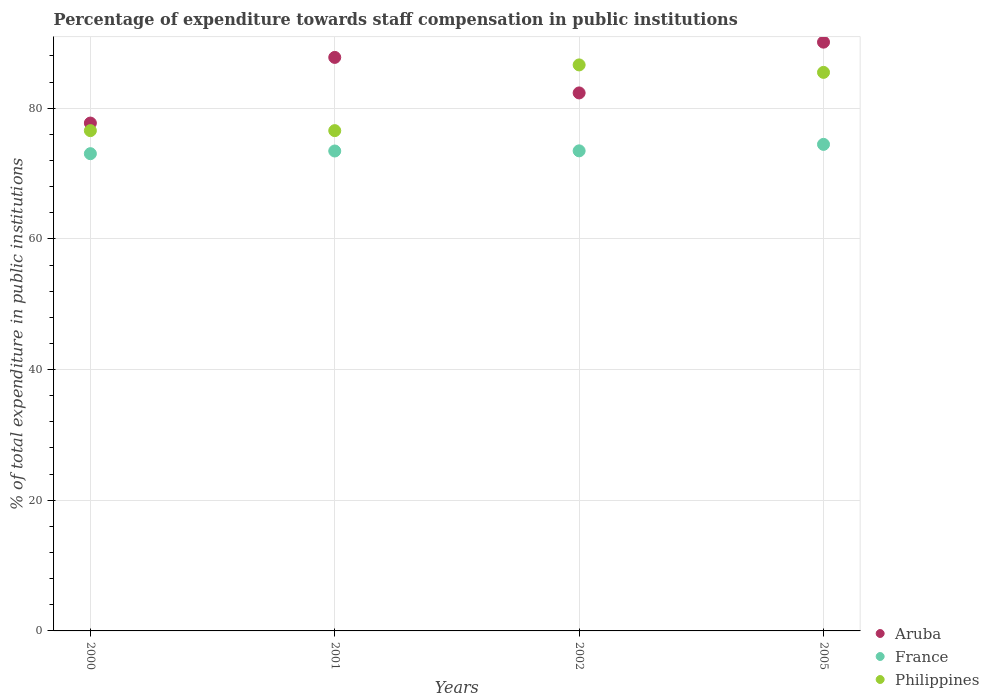What is the percentage of expenditure towards staff compensation in Aruba in 2002?
Provide a short and direct response. 82.34. Across all years, what is the maximum percentage of expenditure towards staff compensation in France?
Offer a terse response. 74.47. Across all years, what is the minimum percentage of expenditure towards staff compensation in Philippines?
Give a very brief answer. 76.57. In which year was the percentage of expenditure towards staff compensation in Aruba maximum?
Ensure brevity in your answer.  2005. In which year was the percentage of expenditure towards staff compensation in Aruba minimum?
Your response must be concise. 2000. What is the total percentage of expenditure towards staff compensation in France in the graph?
Your answer should be very brief. 294.44. What is the difference between the percentage of expenditure towards staff compensation in France in 2002 and that in 2005?
Make the answer very short. -0.99. What is the difference between the percentage of expenditure towards staff compensation in France in 2005 and the percentage of expenditure towards staff compensation in Aruba in 2000?
Your response must be concise. -3.26. What is the average percentage of expenditure towards staff compensation in France per year?
Your answer should be very brief. 73.61. In the year 2001, what is the difference between the percentage of expenditure towards staff compensation in Aruba and percentage of expenditure towards staff compensation in Philippines?
Offer a very short reply. 11.21. What is the ratio of the percentage of expenditure towards staff compensation in France in 2001 to that in 2005?
Ensure brevity in your answer.  0.99. What is the difference between the highest and the second highest percentage of expenditure towards staff compensation in Philippines?
Keep it short and to the point. 1.14. What is the difference between the highest and the lowest percentage of expenditure towards staff compensation in Philippines?
Provide a short and direct response. 10.06. In how many years, is the percentage of expenditure towards staff compensation in Philippines greater than the average percentage of expenditure towards staff compensation in Philippines taken over all years?
Your answer should be compact. 2. Is the sum of the percentage of expenditure towards staff compensation in Aruba in 2001 and 2005 greater than the maximum percentage of expenditure towards staff compensation in Philippines across all years?
Offer a very short reply. Yes. Is the percentage of expenditure towards staff compensation in France strictly greater than the percentage of expenditure towards staff compensation in Philippines over the years?
Your response must be concise. No. Is the percentage of expenditure towards staff compensation in France strictly less than the percentage of expenditure towards staff compensation in Aruba over the years?
Your response must be concise. Yes. How many dotlines are there?
Your response must be concise. 3. How many years are there in the graph?
Ensure brevity in your answer.  4. Are the values on the major ticks of Y-axis written in scientific E-notation?
Keep it short and to the point. No. Does the graph contain grids?
Your answer should be compact. Yes. What is the title of the graph?
Keep it short and to the point. Percentage of expenditure towards staff compensation in public institutions. What is the label or title of the Y-axis?
Keep it short and to the point. % of total expenditure in public institutions. What is the % of total expenditure in public institutions of Aruba in 2000?
Make the answer very short. 77.73. What is the % of total expenditure in public institutions in France in 2000?
Your answer should be very brief. 73.04. What is the % of total expenditure in public institutions in Philippines in 2000?
Give a very brief answer. 76.57. What is the % of total expenditure in public institutions of Aruba in 2001?
Keep it short and to the point. 87.78. What is the % of total expenditure in public institutions of France in 2001?
Ensure brevity in your answer.  73.45. What is the % of total expenditure in public institutions in Philippines in 2001?
Provide a succinct answer. 76.57. What is the % of total expenditure in public institutions of Aruba in 2002?
Your answer should be very brief. 82.34. What is the % of total expenditure in public institutions in France in 2002?
Provide a succinct answer. 73.48. What is the % of total expenditure in public institutions of Philippines in 2002?
Your answer should be very brief. 86.63. What is the % of total expenditure in public institutions of Aruba in 2005?
Provide a succinct answer. 90.11. What is the % of total expenditure in public institutions in France in 2005?
Provide a succinct answer. 74.47. What is the % of total expenditure in public institutions in Philippines in 2005?
Make the answer very short. 85.49. Across all years, what is the maximum % of total expenditure in public institutions in Aruba?
Your answer should be very brief. 90.11. Across all years, what is the maximum % of total expenditure in public institutions in France?
Provide a short and direct response. 74.47. Across all years, what is the maximum % of total expenditure in public institutions of Philippines?
Your response must be concise. 86.63. Across all years, what is the minimum % of total expenditure in public institutions of Aruba?
Keep it short and to the point. 77.73. Across all years, what is the minimum % of total expenditure in public institutions of France?
Your response must be concise. 73.04. Across all years, what is the minimum % of total expenditure in public institutions in Philippines?
Your answer should be very brief. 76.57. What is the total % of total expenditure in public institutions of Aruba in the graph?
Give a very brief answer. 337.96. What is the total % of total expenditure in public institutions of France in the graph?
Provide a succinct answer. 294.44. What is the total % of total expenditure in public institutions in Philippines in the graph?
Offer a very short reply. 325.25. What is the difference between the % of total expenditure in public institutions of Aruba in 2000 and that in 2001?
Keep it short and to the point. -10.05. What is the difference between the % of total expenditure in public institutions in France in 2000 and that in 2001?
Give a very brief answer. -0.41. What is the difference between the % of total expenditure in public institutions of Aruba in 2000 and that in 2002?
Your answer should be very brief. -4.61. What is the difference between the % of total expenditure in public institutions of France in 2000 and that in 2002?
Your answer should be very brief. -0.43. What is the difference between the % of total expenditure in public institutions in Philippines in 2000 and that in 2002?
Provide a short and direct response. -10.06. What is the difference between the % of total expenditure in public institutions of Aruba in 2000 and that in 2005?
Keep it short and to the point. -12.38. What is the difference between the % of total expenditure in public institutions of France in 2000 and that in 2005?
Your response must be concise. -1.42. What is the difference between the % of total expenditure in public institutions in Philippines in 2000 and that in 2005?
Ensure brevity in your answer.  -8.92. What is the difference between the % of total expenditure in public institutions in Aruba in 2001 and that in 2002?
Offer a very short reply. 5.44. What is the difference between the % of total expenditure in public institutions in France in 2001 and that in 2002?
Offer a terse response. -0.02. What is the difference between the % of total expenditure in public institutions of Philippines in 2001 and that in 2002?
Offer a very short reply. -10.06. What is the difference between the % of total expenditure in public institutions of Aruba in 2001 and that in 2005?
Your answer should be very brief. -2.33. What is the difference between the % of total expenditure in public institutions of France in 2001 and that in 2005?
Ensure brevity in your answer.  -1.01. What is the difference between the % of total expenditure in public institutions of Philippines in 2001 and that in 2005?
Your answer should be compact. -8.92. What is the difference between the % of total expenditure in public institutions in Aruba in 2002 and that in 2005?
Ensure brevity in your answer.  -7.77. What is the difference between the % of total expenditure in public institutions in France in 2002 and that in 2005?
Offer a terse response. -0.99. What is the difference between the % of total expenditure in public institutions of Philippines in 2002 and that in 2005?
Offer a terse response. 1.14. What is the difference between the % of total expenditure in public institutions of Aruba in 2000 and the % of total expenditure in public institutions of France in 2001?
Keep it short and to the point. 4.28. What is the difference between the % of total expenditure in public institutions of Aruba in 2000 and the % of total expenditure in public institutions of Philippines in 2001?
Keep it short and to the point. 1.16. What is the difference between the % of total expenditure in public institutions of France in 2000 and the % of total expenditure in public institutions of Philippines in 2001?
Your answer should be compact. -3.53. What is the difference between the % of total expenditure in public institutions of Aruba in 2000 and the % of total expenditure in public institutions of France in 2002?
Offer a terse response. 4.25. What is the difference between the % of total expenditure in public institutions of France in 2000 and the % of total expenditure in public institutions of Philippines in 2002?
Offer a very short reply. -13.59. What is the difference between the % of total expenditure in public institutions in Aruba in 2000 and the % of total expenditure in public institutions in France in 2005?
Provide a succinct answer. 3.26. What is the difference between the % of total expenditure in public institutions of Aruba in 2000 and the % of total expenditure in public institutions of Philippines in 2005?
Your response must be concise. -7.76. What is the difference between the % of total expenditure in public institutions of France in 2000 and the % of total expenditure in public institutions of Philippines in 2005?
Your answer should be very brief. -12.44. What is the difference between the % of total expenditure in public institutions in Aruba in 2001 and the % of total expenditure in public institutions in France in 2002?
Ensure brevity in your answer.  14.3. What is the difference between the % of total expenditure in public institutions of Aruba in 2001 and the % of total expenditure in public institutions of Philippines in 2002?
Keep it short and to the point. 1.15. What is the difference between the % of total expenditure in public institutions of France in 2001 and the % of total expenditure in public institutions of Philippines in 2002?
Offer a very short reply. -13.18. What is the difference between the % of total expenditure in public institutions in Aruba in 2001 and the % of total expenditure in public institutions in France in 2005?
Provide a short and direct response. 13.31. What is the difference between the % of total expenditure in public institutions in Aruba in 2001 and the % of total expenditure in public institutions in Philippines in 2005?
Provide a short and direct response. 2.29. What is the difference between the % of total expenditure in public institutions of France in 2001 and the % of total expenditure in public institutions of Philippines in 2005?
Ensure brevity in your answer.  -12.03. What is the difference between the % of total expenditure in public institutions in Aruba in 2002 and the % of total expenditure in public institutions in France in 2005?
Your answer should be very brief. 7.87. What is the difference between the % of total expenditure in public institutions of Aruba in 2002 and the % of total expenditure in public institutions of Philippines in 2005?
Provide a short and direct response. -3.15. What is the difference between the % of total expenditure in public institutions of France in 2002 and the % of total expenditure in public institutions of Philippines in 2005?
Provide a short and direct response. -12.01. What is the average % of total expenditure in public institutions of Aruba per year?
Provide a short and direct response. 84.49. What is the average % of total expenditure in public institutions of France per year?
Your answer should be very brief. 73.61. What is the average % of total expenditure in public institutions in Philippines per year?
Offer a terse response. 81.31. In the year 2000, what is the difference between the % of total expenditure in public institutions of Aruba and % of total expenditure in public institutions of France?
Provide a short and direct response. 4.69. In the year 2000, what is the difference between the % of total expenditure in public institutions in Aruba and % of total expenditure in public institutions in Philippines?
Keep it short and to the point. 1.16. In the year 2000, what is the difference between the % of total expenditure in public institutions in France and % of total expenditure in public institutions in Philippines?
Your response must be concise. -3.53. In the year 2001, what is the difference between the % of total expenditure in public institutions of Aruba and % of total expenditure in public institutions of France?
Your answer should be compact. 14.32. In the year 2001, what is the difference between the % of total expenditure in public institutions in Aruba and % of total expenditure in public institutions in Philippines?
Provide a short and direct response. 11.21. In the year 2001, what is the difference between the % of total expenditure in public institutions in France and % of total expenditure in public institutions in Philippines?
Make the answer very short. -3.12. In the year 2002, what is the difference between the % of total expenditure in public institutions of Aruba and % of total expenditure in public institutions of France?
Your response must be concise. 8.87. In the year 2002, what is the difference between the % of total expenditure in public institutions in Aruba and % of total expenditure in public institutions in Philippines?
Your response must be concise. -4.29. In the year 2002, what is the difference between the % of total expenditure in public institutions in France and % of total expenditure in public institutions in Philippines?
Give a very brief answer. -13.15. In the year 2005, what is the difference between the % of total expenditure in public institutions of Aruba and % of total expenditure in public institutions of France?
Your answer should be compact. 15.65. In the year 2005, what is the difference between the % of total expenditure in public institutions of Aruba and % of total expenditure in public institutions of Philippines?
Keep it short and to the point. 4.63. In the year 2005, what is the difference between the % of total expenditure in public institutions in France and % of total expenditure in public institutions in Philippines?
Ensure brevity in your answer.  -11.02. What is the ratio of the % of total expenditure in public institutions in Aruba in 2000 to that in 2001?
Your response must be concise. 0.89. What is the ratio of the % of total expenditure in public institutions in Aruba in 2000 to that in 2002?
Provide a short and direct response. 0.94. What is the ratio of the % of total expenditure in public institutions in Philippines in 2000 to that in 2002?
Your answer should be compact. 0.88. What is the ratio of the % of total expenditure in public institutions of Aruba in 2000 to that in 2005?
Your answer should be compact. 0.86. What is the ratio of the % of total expenditure in public institutions in France in 2000 to that in 2005?
Make the answer very short. 0.98. What is the ratio of the % of total expenditure in public institutions in Philippines in 2000 to that in 2005?
Your answer should be compact. 0.9. What is the ratio of the % of total expenditure in public institutions of Aruba in 2001 to that in 2002?
Give a very brief answer. 1.07. What is the ratio of the % of total expenditure in public institutions in Philippines in 2001 to that in 2002?
Your answer should be very brief. 0.88. What is the ratio of the % of total expenditure in public institutions of Aruba in 2001 to that in 2005?
Keep it short and to the point. 0.97. What is the ratio of the % of total expenditure in public institutions of France in 2001 to that in 2005?
Your answer should be very brief. 0.99. What is the ratio of the % of total expenditure in public institutions of Philippines in 2001 to that in 2005?
Your answer should be very brief. 0.9. What is the ratio of the % of total expenditure in public institutions of Aruba in 2002 to that in 2005?
Provide a succinct answer. 0.91. What is the ratio of the % of total expenditure in public institutions of France in 2002 to that in 2005?
Provide a succinct answer. 0.99. What is the ratio of the % of total expenditure in public institutions of Philippines in 2002 to that in 2005?
Your answer should be compact. 1.01. What is the difference between the highest and the second highest % of total expenditure in public institutions in Aruba?
Offer a very short reply. 2.33. What is the difference between the highest and the second highest % of total expenditure in public institutions in France?
Your answer should be very brief. 0.99. What is the difference between the highest and the second highest % of total expenditure in public institutions of Philippines?
Offer a terse response. 1.14. What is the difference between the highest and the lowest % of total expenditure in public institutions in Aruba?
Offer a very short reply. 12.38. What is the difference between the highest and the lowest % of total expenditure in public institutions of France?
Provide a succinct answer. 1.42. What is the difference between the highest and the lowest % of total expenditure in public institutions of Philippines?
Make the answer very short. 10.06. 